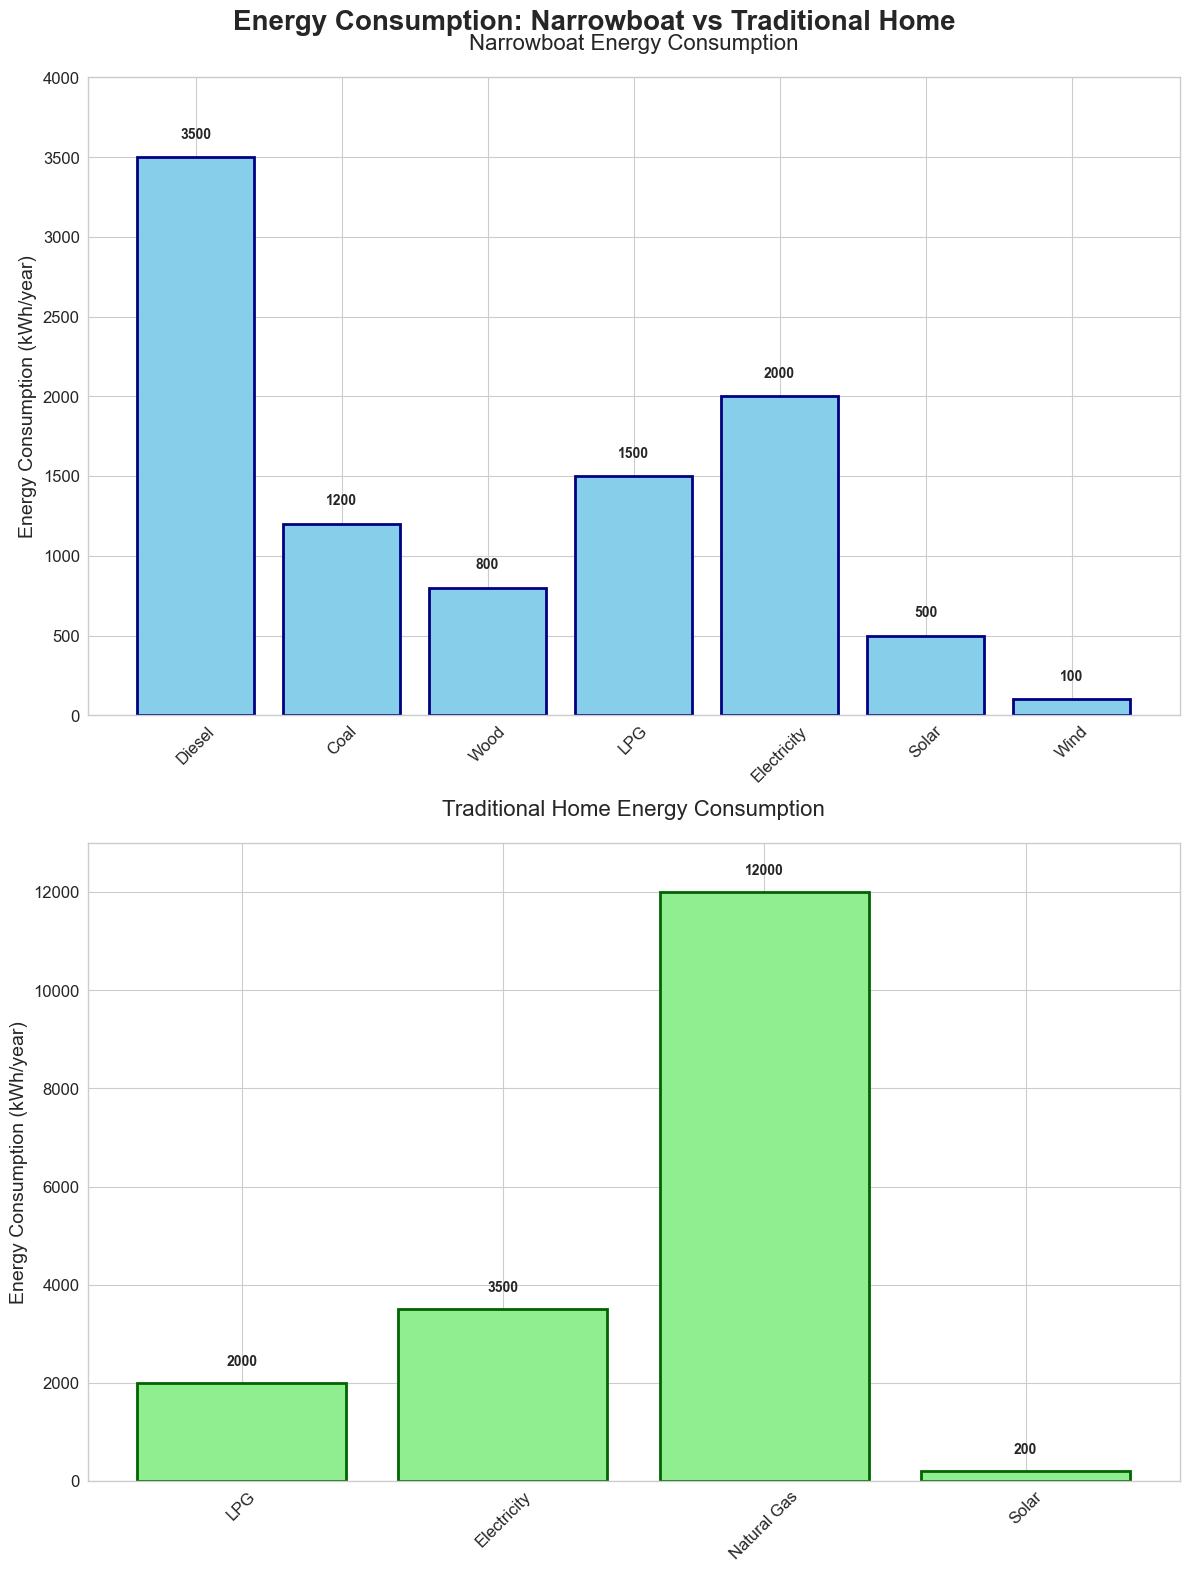What's the title of the figure? The title is usually shown at the top of the figure. Here, it reads "Energy Consumption: Narrowboat vs Traditional Home".
Answer: Energy Consumption: Narrowboat vs Traditional Home Which fuel type has the highest energy consumption for traditional homes? By looking at the second subplot, Natural Gas has the highest bar, which means it has the highest energy consumption.
Answer: Natural Gas What is the total energy consumption for a narrowboat across all fuel types? To find this, sum up the kWh/year values for all the fuels listed for the narrowboat: Diesel (3500) + Coal (1200) + Wood (800) + LPG (1500) + Electricity (2000) + Solar (500) + Wind (100) = 9600 kWh/year.
Answer: 9600 kWh/year How does the electricity consumption of traditional homes compare to narrowboats? By comparing the heights of the bars for Electricity in both subplots, we see that traditional homes use 3500 kWh/year while narrowboats use 2000 kWh/year. Traditional homes use more electricity.
Answer: Traditional homes use more What's the combined energy consumption from LPG and Electricity for traditional homes, compared to traditional homes' Natural Gas consumption? Combine the energy consumption for LPG (2000) and Electricity (3500) in traditional homes: 2000 + 3500 = 5500 kWh/year. Compare this to Natural Gas which is 12000 kWh/year. 12000 is greater than 5500.
Answer: Natural Gas use is higher Which energy source appears in both narrowboats and traditional homes but with different consumption values? By observing both subplots, LPG and Electricity are used in both narrowboats and traditional homes with different values.
Answer: LPG and Electricity What is the least used energy source for narrowboats, and how much is used? In the narrowboat subplot, the shortest bar represents Wind, which has a value of 100 kWh/year.
Answer: Wind, 100 kWh/year How much more energy does a traditional home consume from Electricity than a narrowboat? Calculate the difference in energy consumption for Electricity: 3500 kWh/year (traditional homes) - 2000 kWh/year (narrowboats) = 1500 kWh/year.
Answer: 1500 kWh/year Identify a renewable energy source used by narrowboats. By examining the narrowboat subplot and identifying renewable energy sources, Solar and Wind are renewable energy sources used by narrowboats.
Answer: Solar and Wind 